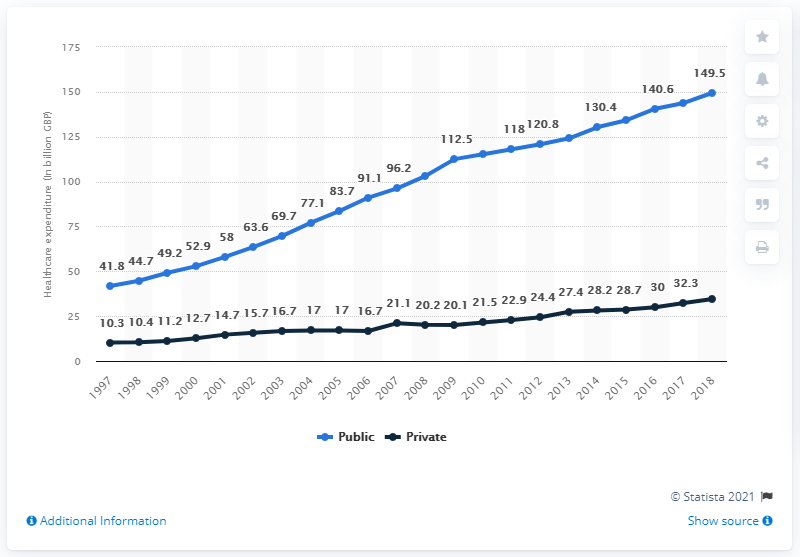Point out several critical features in this image. From 2009 to 2018, the blue line moved a total of 37 points. In 2018, the public healthcare expenditure in the UK was 149.5 billion pounds. The data in the public domain crossed the 100 mark in the year 2009. In 2018, the private sector's healthcare expenditure was approximately 34.5%. Healthcare spending in the UK has increased since the year 1997. 